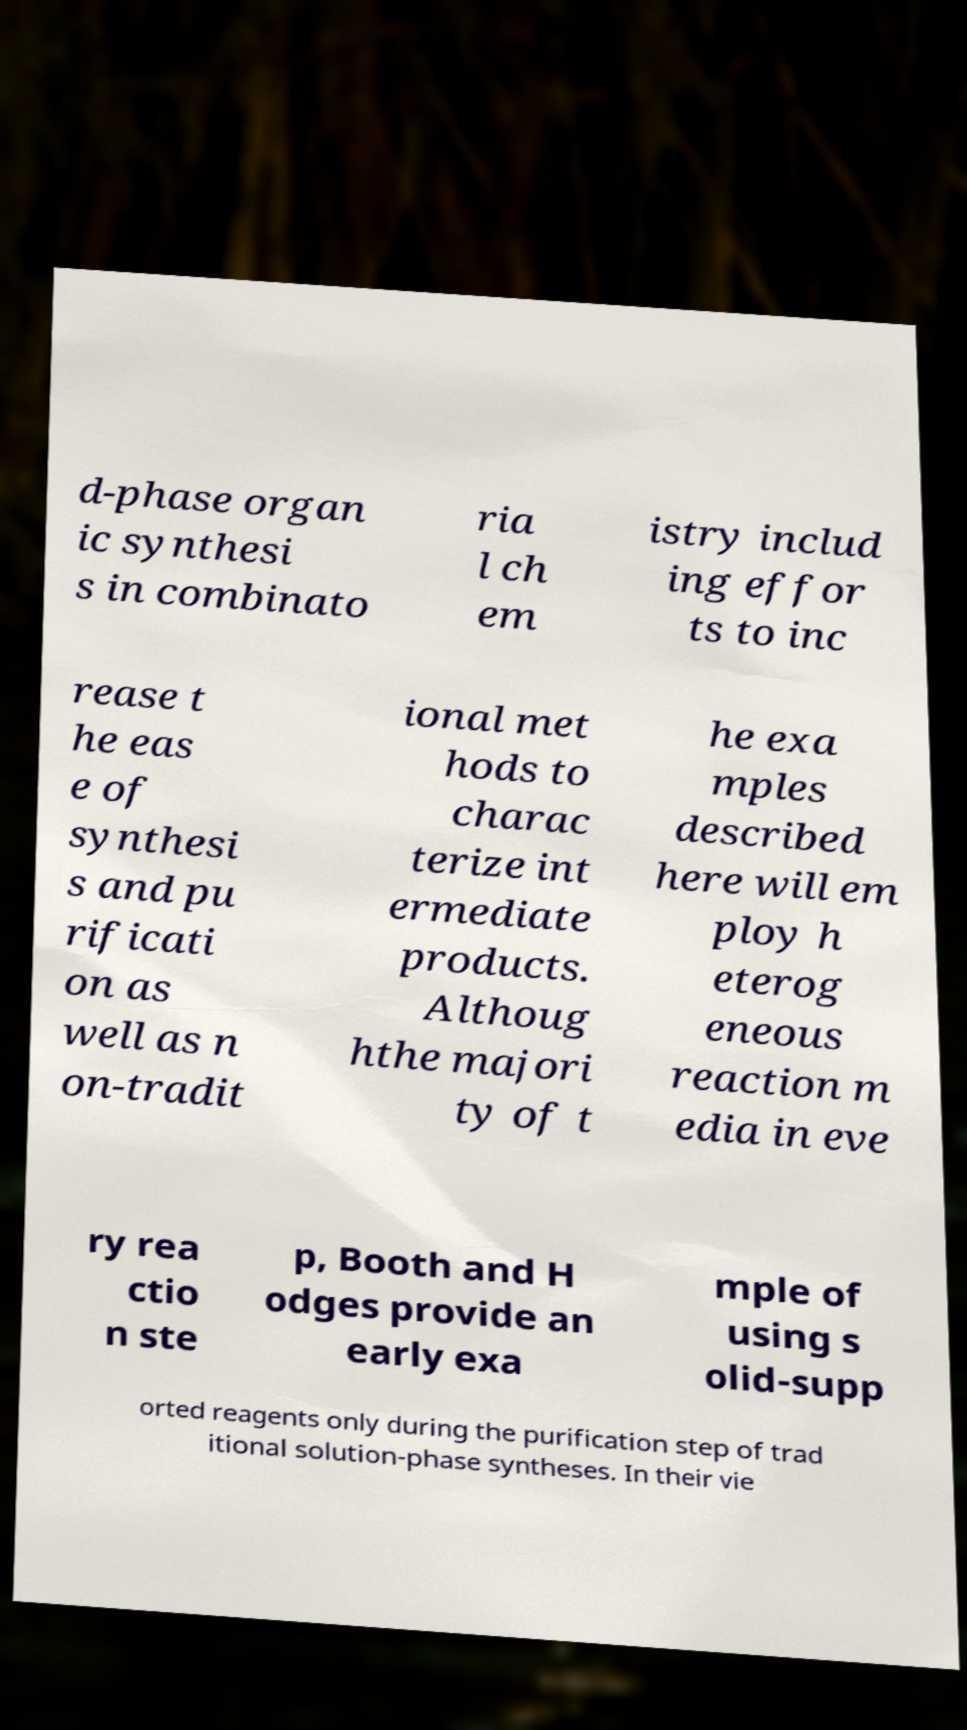Can you accurately transcribe the text from the provided image for me? d-phase organ ic synthesi s in combinato ria l ch em istry includ ing effor ts to inc rease t he eas e of synthesi s and pu rificati on as well as n on-tradit ional met hods to charac terize int ermediate products. Althoug hthe majori ty of t he exa mples described here will em ploy h eterog eneous reaction m edia in eve ry rea ctio n ste p, Booth and H odges provide an early exa mple of using s olid-supp orted reagents only during the purification step of trad itional solution-phase syntheses. In their vie 